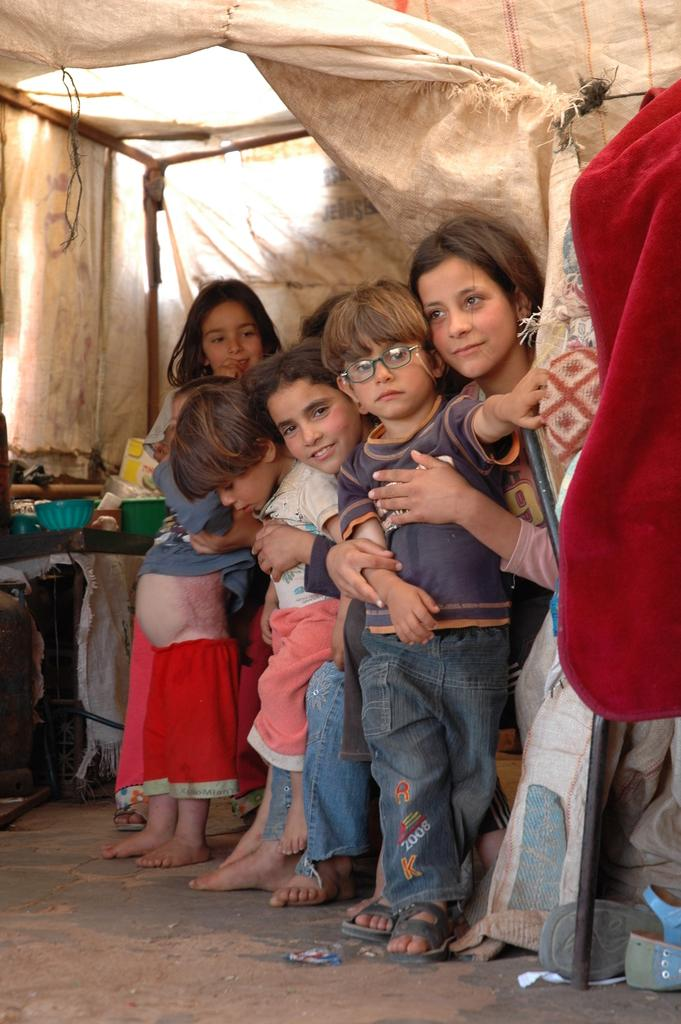Who or what can be seen in the image? There are people in the image. What type of material is visible in the image? There is cloth visible in the image. What type of footwear is visible in the image? There is footwear visible in the image. What type of shelter is present in the image? There is a tent in the image. What can be seen in the background of the image? There is a bowl and objects on a table in the background of the image. What type of orange is being used as a prop in the image? There is no orange present in the image. What is the value of the objects on the table in the image? The value of the objects on the table cannot be determined from the image alone. 